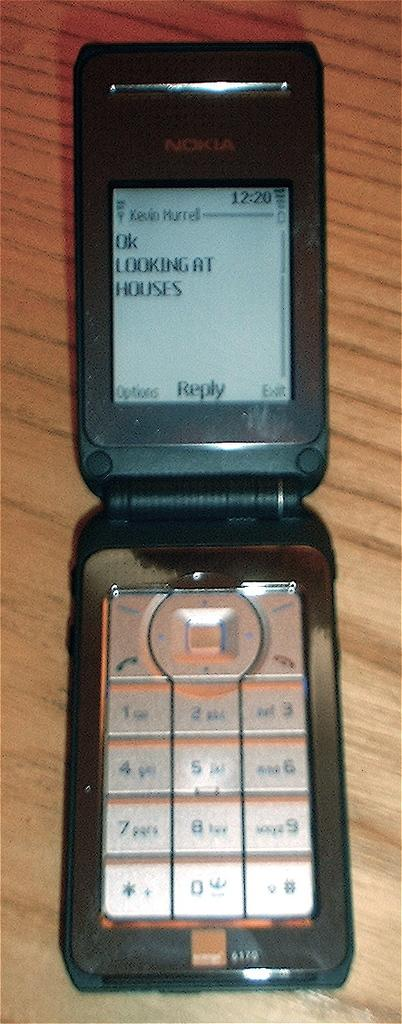Provide a one-sentence caption for the provided image. A black flip phone with a messaged displayed on the screen that says "Ok looking at houses". 